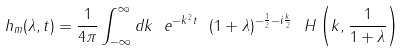Convert formula to latex. <formula><loc_0><loc_0><loc_500><loc_500>h _ { m } ( \lambda , t ) = \frac { 1 } { 4 \pi } \int _ { - \infty } ^ { \infty } d k \ e ^ { - k ^ { 2 } t } \ ( 1 + \lambda ) ^ { - \frac { 1 } { 2 } - i \frac { k } { 2 } } { \ H \left ( k , \frac { 1 } { 1 + \lambda } \right ) }</formula> 